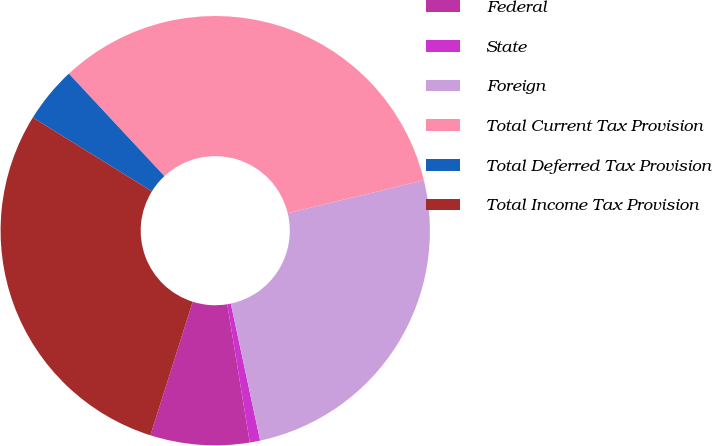Convert chart to OTSL. <chart><loc_0><loc_0><loc_500><loc_500><pie_chart><fcel>Federal<fcel>State<fcel>Foreign<fcel>Total Current Tax Provision<fcel>Total Deferred Tax Provision<fcel>Total Income Tax Provision<nl><fcel>7.46%<fcel>0.78%<fcel>25.42%<fcel>33.17%<fcel>4.22%<fcel>28.95%<nl></chart> 